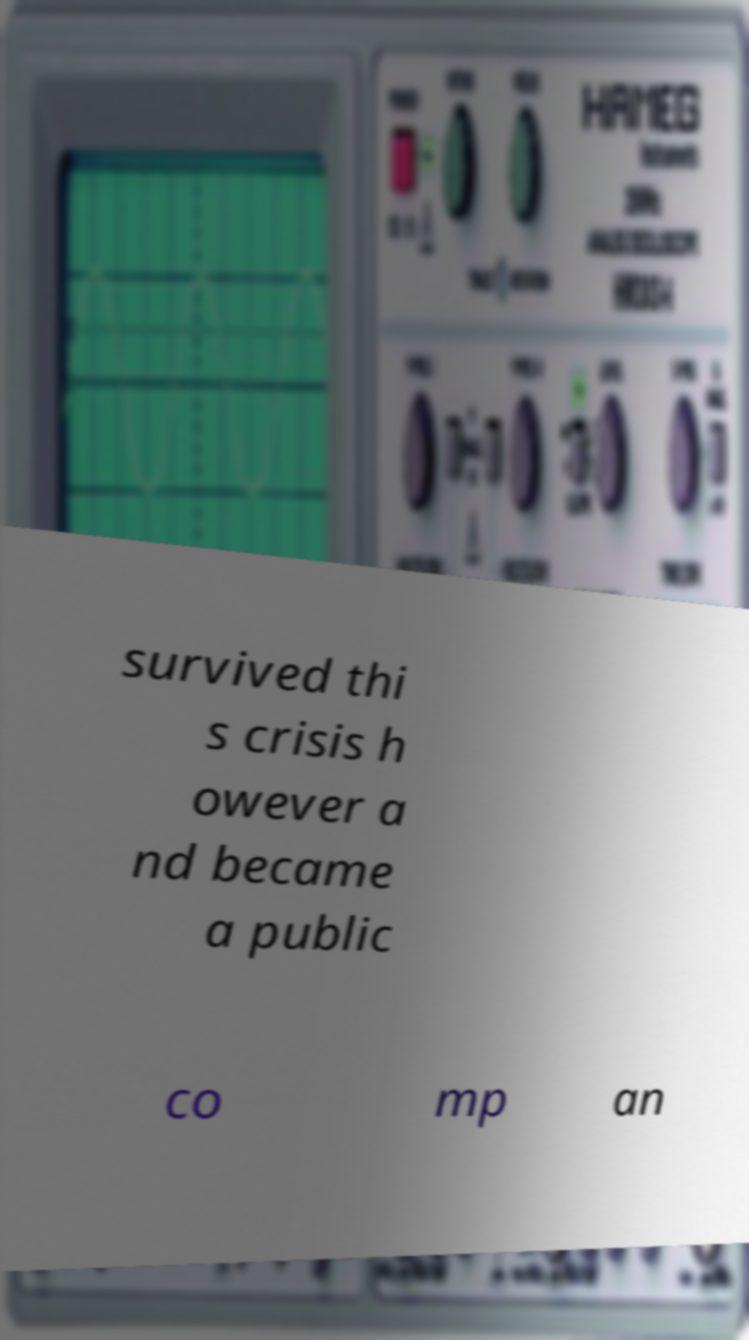Could you extract and type out the text from this image? survived thi s crisis h owever a nd became a public co mp an 